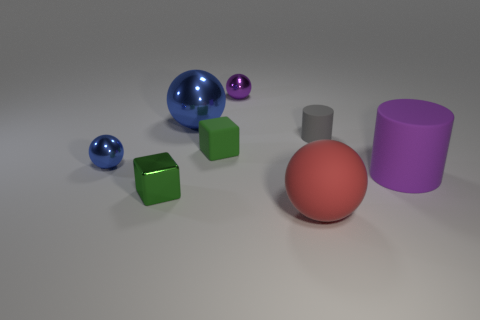The small thing that is the same color as the big matte cylinder is what shape?
Offer a terse response. Sphere. Is the number of small spheres that are in front of the tiny purple metal thing greater than the number of large balls that are behind the small metallic cube?
Offer a terse response. No. There is a green rubber cube on the left side of the tiny object that is behind the small thing to the right of the big red ball; what is its size?
Your answer should be compact. Small. Are there any objects that have the same color as the large rubber cylinder?
Keep it short and to the point. Yes. How many red metallic cubes are there?
Offer a terse response. 0. The purple thing that is in front of the block behind the matte thing that is right of the small gray rubber thing is made of what material?
Provide a succinct answer. Rubber. Are there any large brown cylinders that have the same material as the big blue ball?
Your answer should be very brief. No. Do the small gray object and the large red object have the same material?
Make the answer very short. Yes. How many spheres are blue things or purple things?
Provide a succinct answer. 3. What is the color of the other cylinder that is the same material as the tiny cylinder?
Your answer should be compact. Purple. 